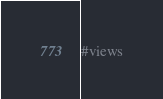Convert code to text. <code><loc_0><loc_0><loc_500><loc_500><_Python_>#views
</code> 